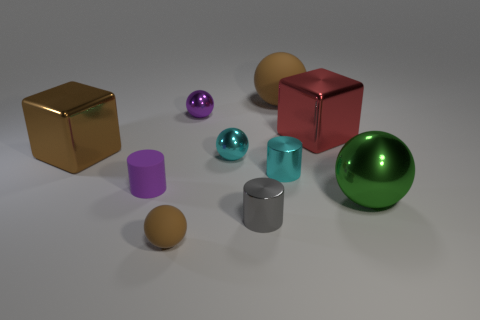What is the shape of the small object that is the same color as the large rubber sphere?
Your answer should be very brief. Sphere. What size is the other matte thing that is the same color as the large rubber object?
Your answer should be compact. Small. There is a brown thing in front of the brown metal thing; what is it made of?
Keep it short and to the point. Rubber. Do the big brown metallic object and the red object have the same shape?
Offer a very short reply. Yes. How many other objects are there of the same shape as the purple metallic object?
Your response must be concise. 4. There is a cylinder on the right side of the small gray object; what is its color?
Ensure brevity in your answer.  Cyan. Do the purple matte cylinder and the gray metallic cylinder have the same size?
Make the answer very short. Yes. There is a cylinder to the left of the small cyan thing that is to the left of the tiny gray object; what is it made of?
Give a very brief answer. Rubber. What number of rubber things have the same color as the large shiny sphere?
Your response must be concise. 0. Are there fewer big green shiny balls behind the small cyan metallic cylinder than tiny gray cylinders?
Offer a very short reply. Yes. 